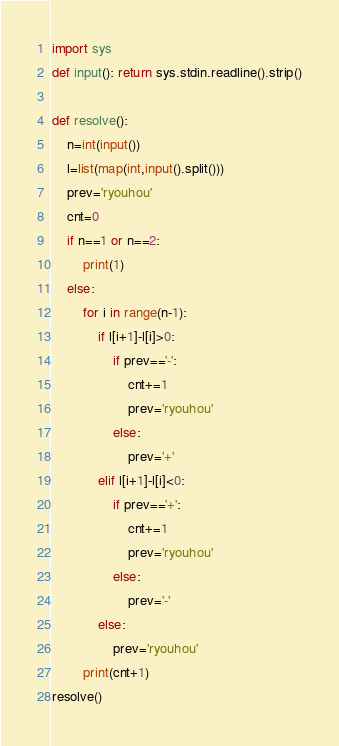Convert code to text. <code><loc_0><loc_0><loc_500><loc_500><_Python_>import sys
def input(): return sys.stdin.readline().strip()

def resolve():
    n=int(input())
    l=list(map(int,input().split()))
    prev='ryouhou'
    cnt=0
    if n==1 or n==2:
        print(1)
    else:
        for i in range(n-1):
            if l[i+1]-l[i]>0:
                if prev=='-':
                    cnt+=1
                    prev='ryouhou'
                else:
                    prev='+'
            elif l[i+1]-l[i]<0:
                if prev=='+':
                    cnt+=1
                    prev='ryouhou'
                else:
                    prev='-'
            else:
                prev='ryouhou'
        print(cnt+1)
resolve()</code> 